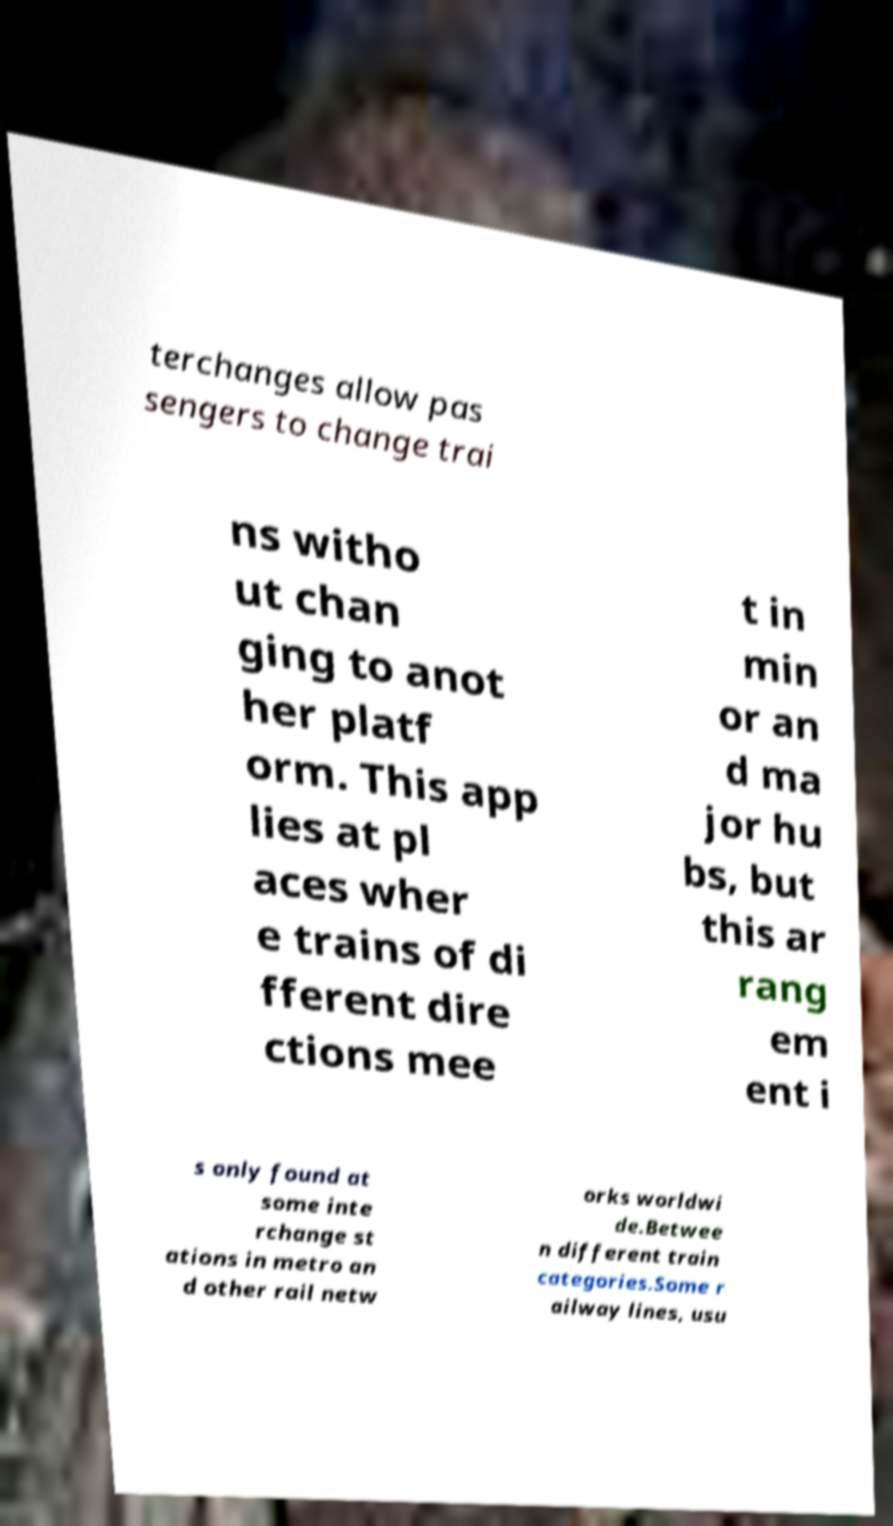What messages or text are displayed in this image? I need them in a readable, typed format. terchanges allow pas sengers to change trai ns witho ut chan ging to anot her platf orm. This app lies at pl aces wher e trains of di fferent dire ctions mee t in min or an d ma jor hu bs, but this ar rang em ent i s only found at some inte rchange st ations in metro an d other rail netw orks worldwi de.Betwee n different train categories.Some r ailway lines, usu 